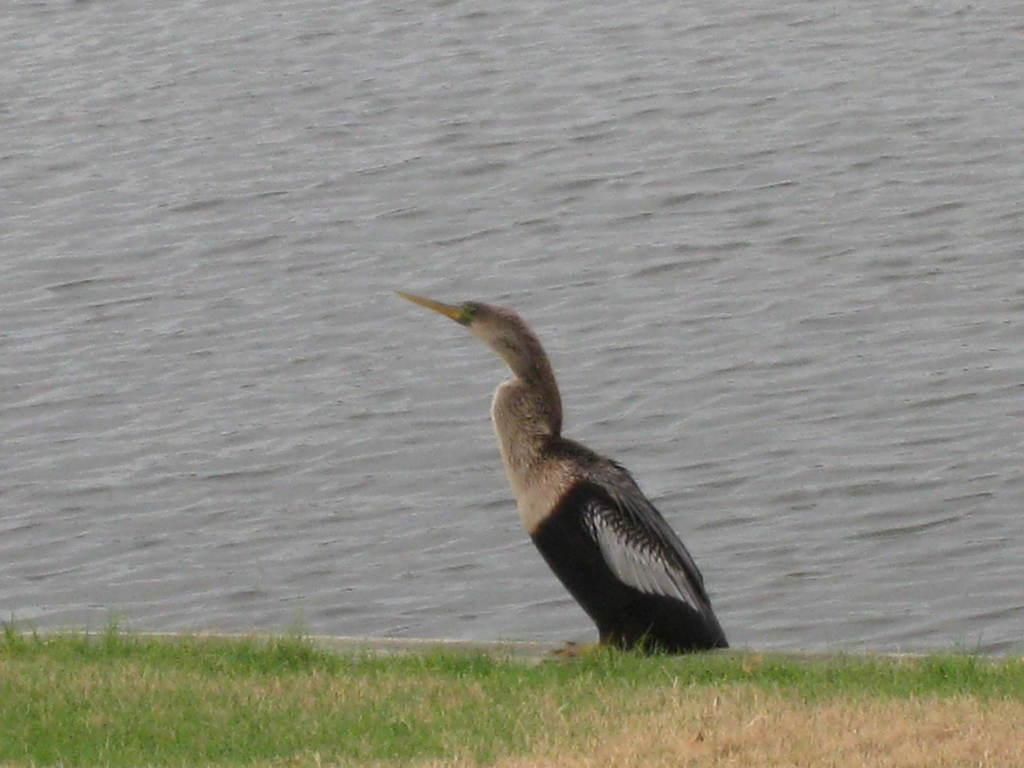What type of animal can be seen in the picture? There is a bird in the picture. Where is the bird located in the picture? The bird is sitting on the grass. What else can be seen in the picture besides the bird? There is water visible in the picture. How many sisters are present in the picture? There are no sisters mentioned or depicted in the picture; it features a bird sitting on the grass with water visible in the background. 